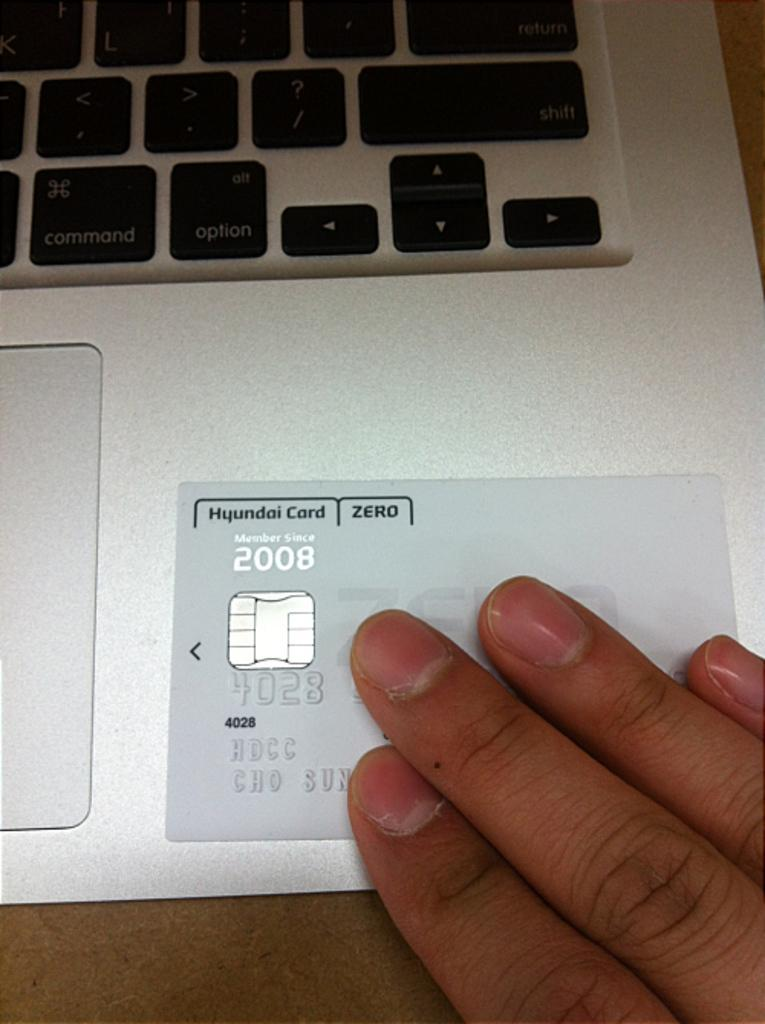<image>
Relay a brief, clear account of the picture shown. An Hyundai Card belonging to someone who has been a member since 2008. 